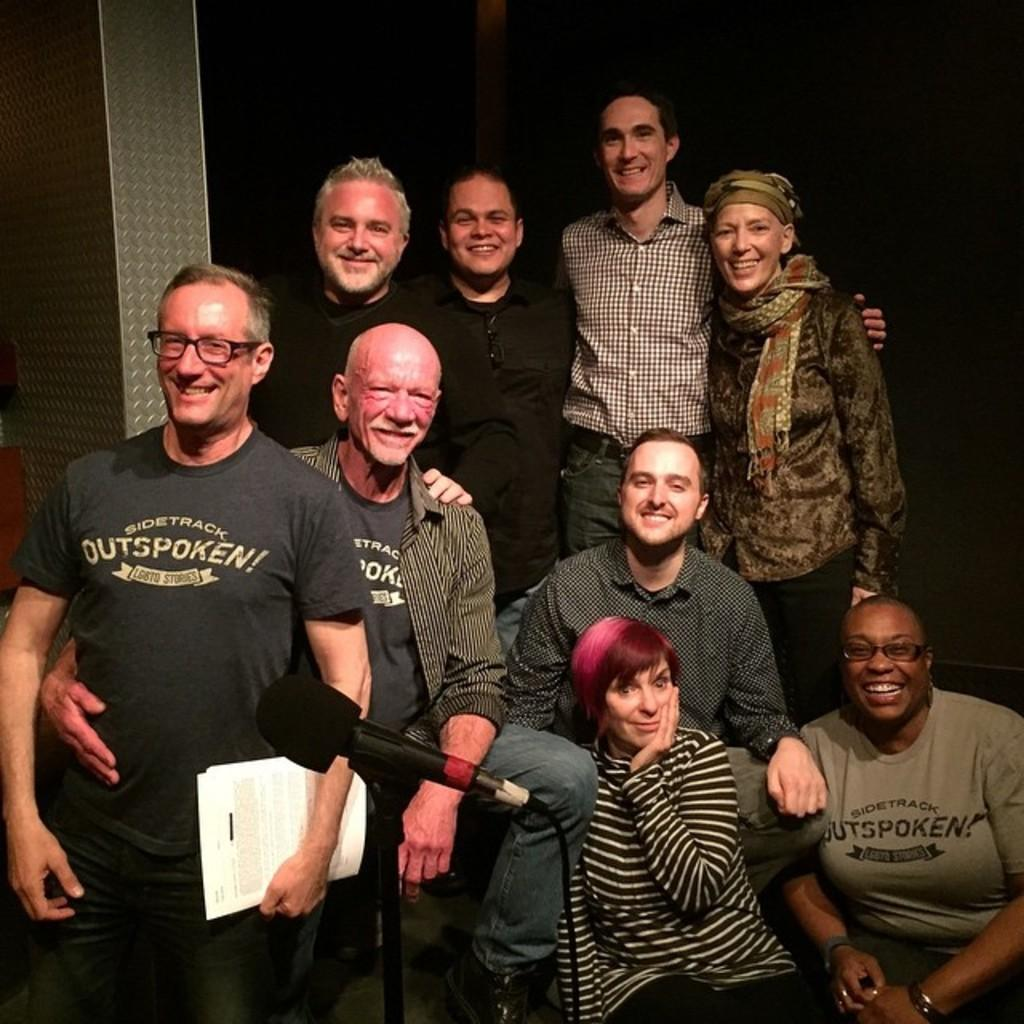How many people are in the image? There are people in the image, but the exact number is not specified. Can you describe the position of one person in the image? One person is standing on the left side of the image. What is the person on the left side holding? The person on the left is holding papers. What object is located in the front of the image? There is a microphone in the front of the image. How many tickets does the person on the right have in the image? There is no mention of tickets or a person on the right in the image. 